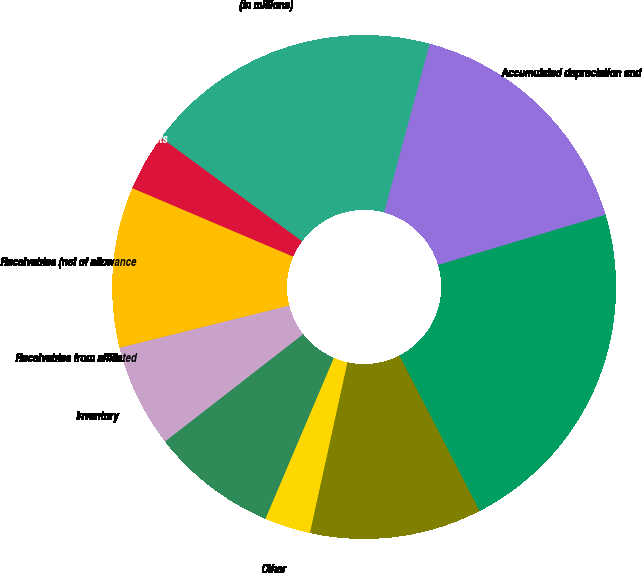Convert chart to OTSL. <chart><loc_0><loc_0><loc_500><loc_500><pie_chart><fcel>(in millions)<fcel>Cash and cash equivalents<fcel>Receivables (net of allowance<fcel>Receivables from affiliated<fcel>Inventory<fcel>Regulatory assets<fcel>Other<fcel>Total current assets<fcel>Cost<fcel>Accumulated depreciation and<nl><fcel>19.11%<fcel>3.68%<fcel>10.29%<fcel>0.01%<fcel>6.62%<fcel>8.09%<fcel>2.95%<fcel>11.03%<fcel>22.05%<fcel>16.17%<nl></chart> 